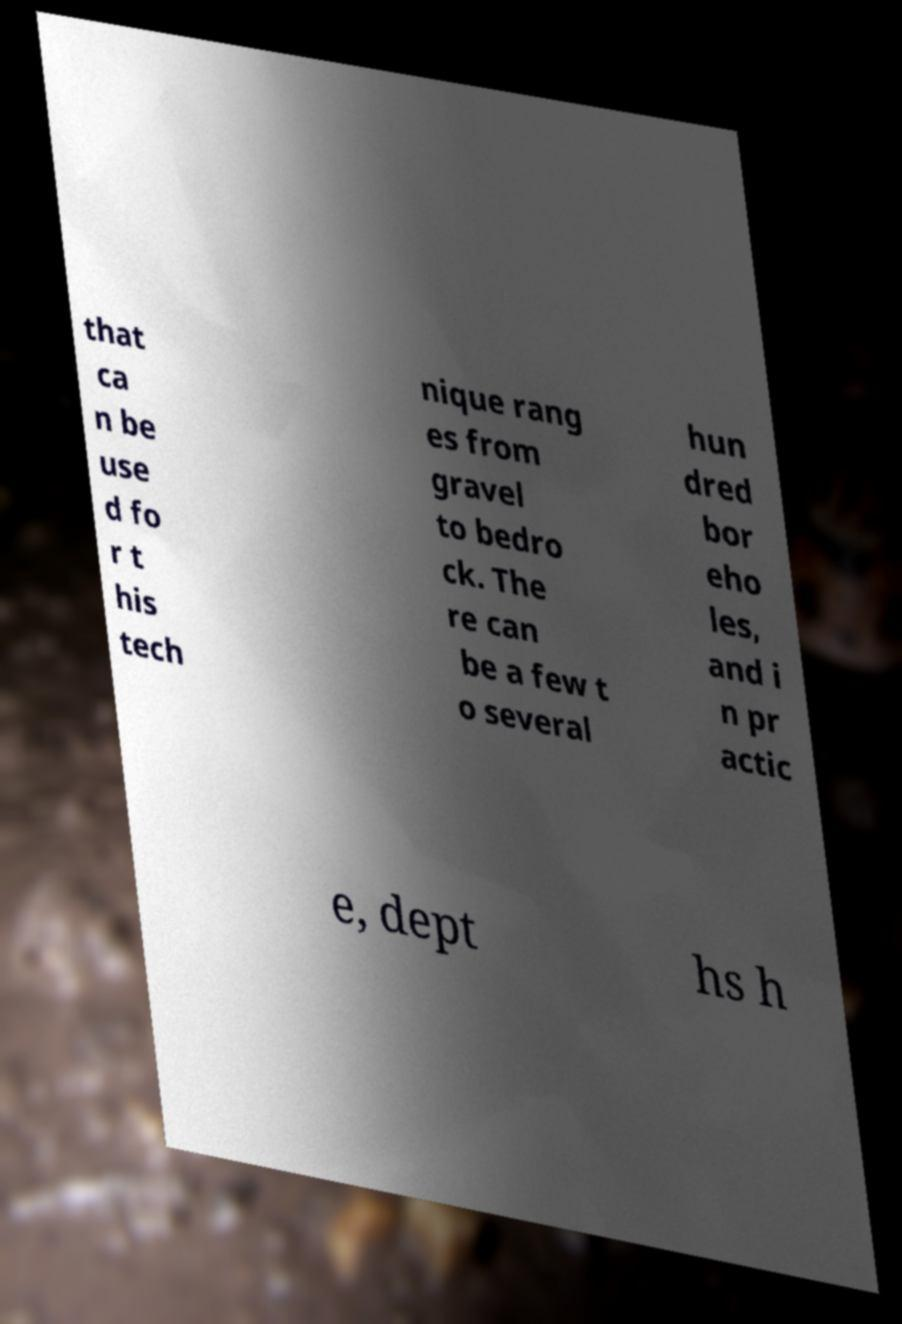Could you assist in decoding the text presented in this image and type it out clearly? that ca n be use d fo r t his tech nique rang es from gravel to bedro ck. The re can be a few t o several hun dred bor eho les, and i n pr actic e, dept hs h 